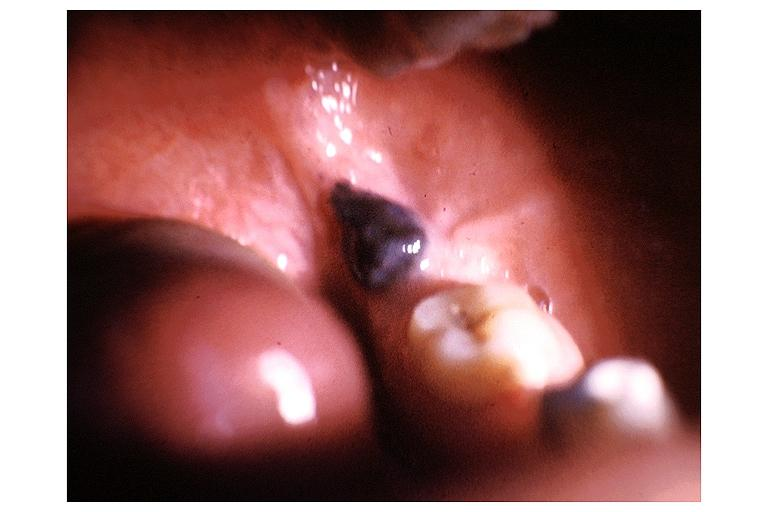does this image show nevus?
Answer the question using a single word or phrase. Yes 